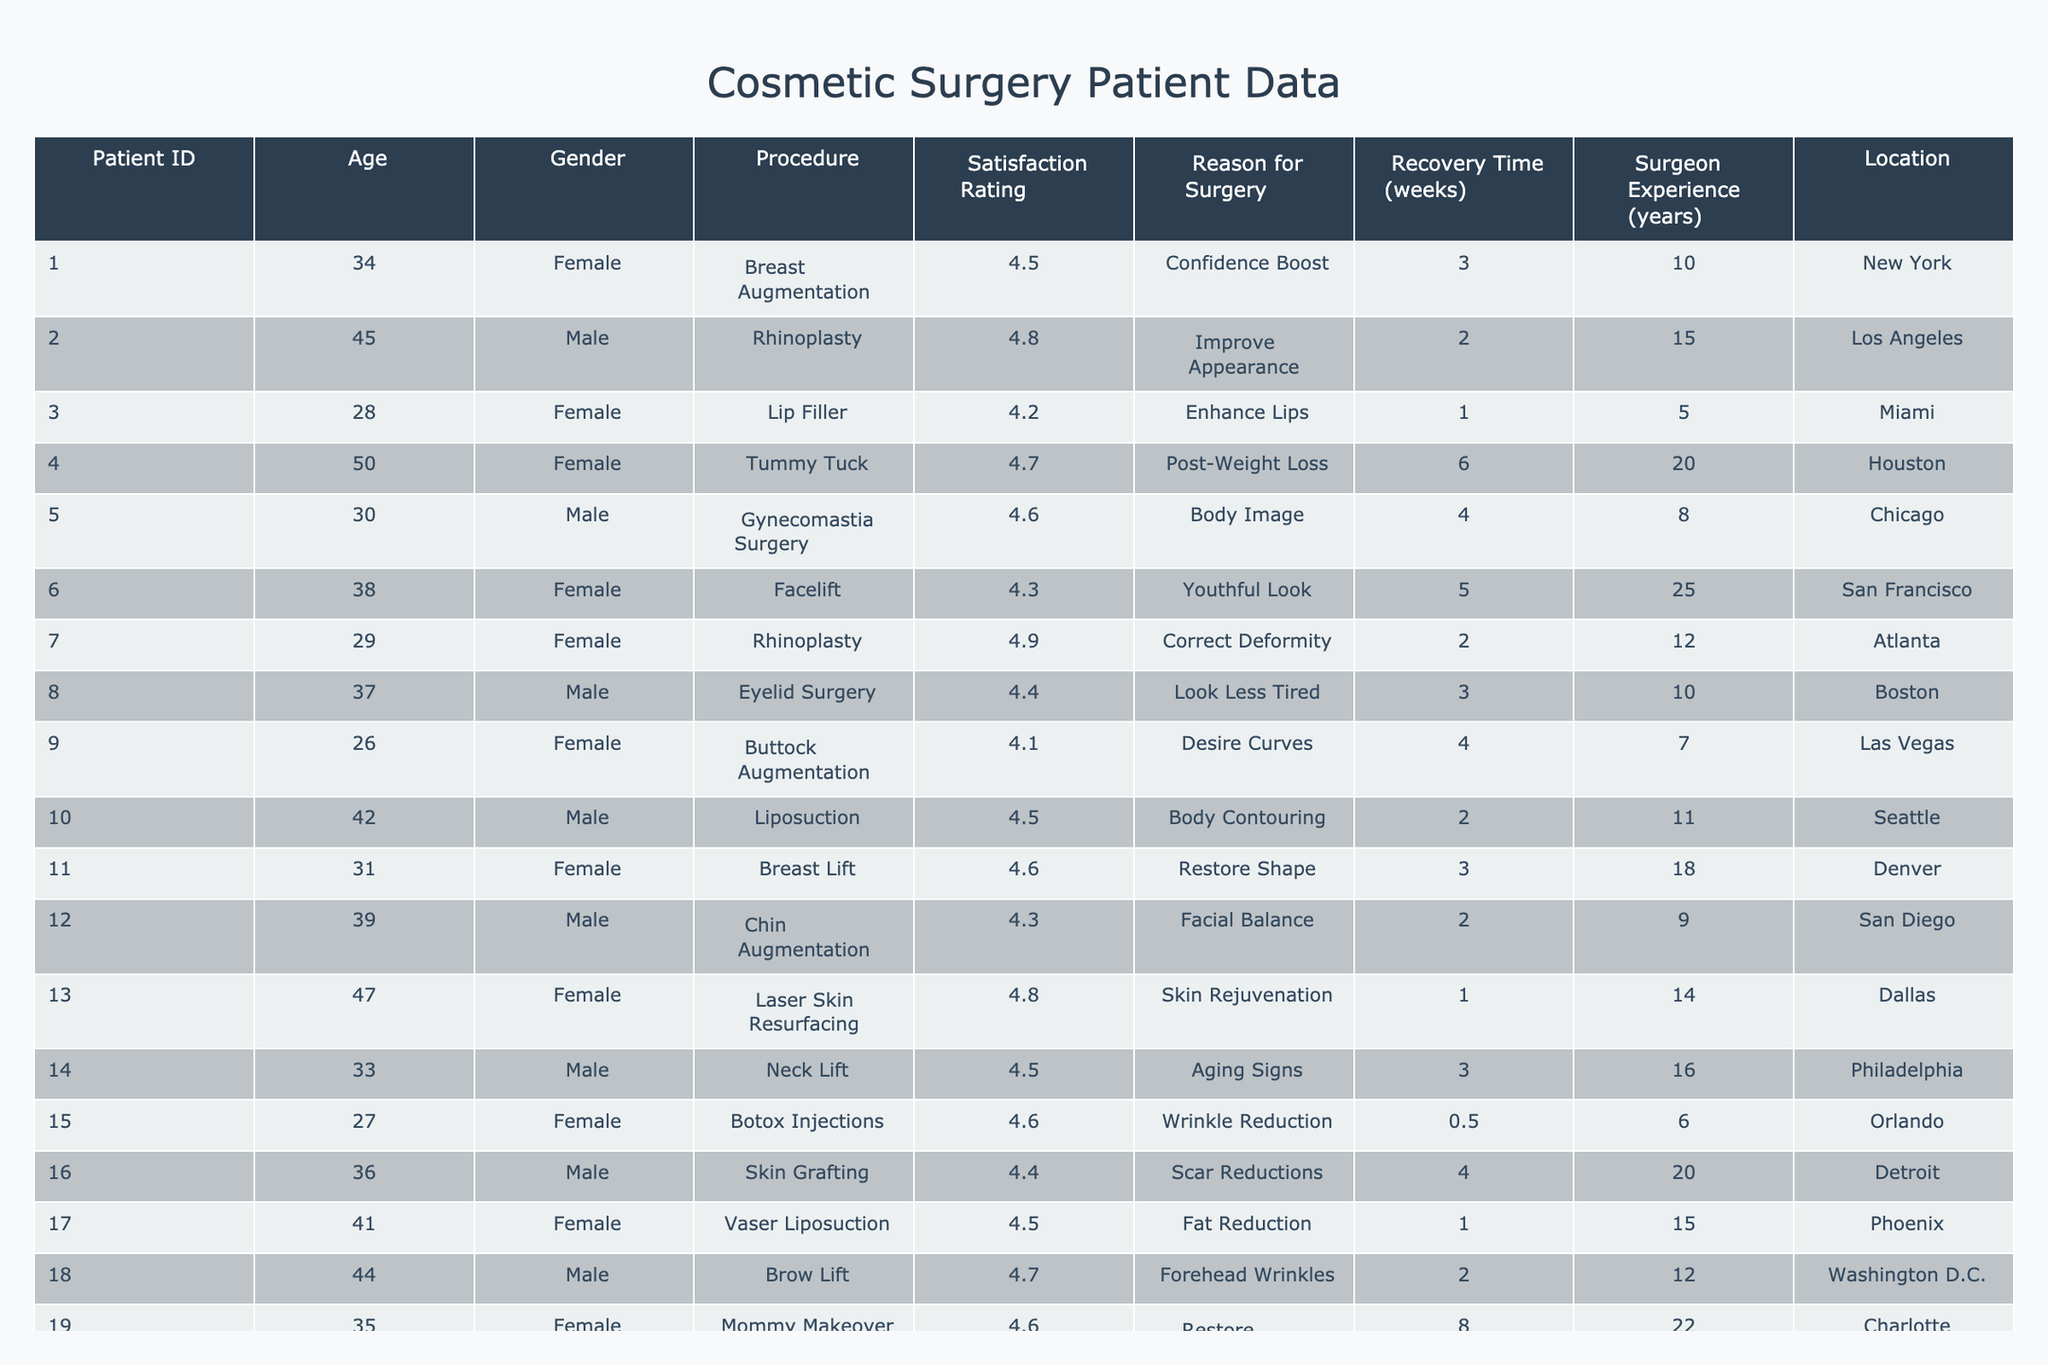What is the satisfaction rating for the Breast Augmentation procedure? In the table, I can find the row with "Breast Augmentation" under the Procedure column. The satisfaction rating in that row is 4.5.
Answer: 4.5 How many patients had a Recovery Time of 2 weeks? By inspecting the table, there are three patients (IDs 2, 12, and 18) who had a Recovery Time of 2 weeks.
Answer: 3 What is the average satisfaction rating for male patients? To find the average for male patients, I sum their satisfaction ratings: 4.8 (Rhinoplasty) + 4.6 (Gynecomastia Surgery) + 4.4 (Eyelid Surgery) + 4.3 (Chin Augmentation) + 4.5 (Neck Lift) + 4.4 (Skin Grafting) + 4.7 (Brow Lift) + 4.2 (Arm Lift) = 35.9. There are 8 male patients, so the average is 35.9 / 8 = 4.4875, rounded to 4.49.
Answer: 4.49 Which procedure had the longest Recovery Time, and what was that time? The longest Recovery Time listed in the table is 8 weeks, associated with the Mommy Makeover procedure performed on a 35-year-old female patient.
Answer: Mommy Makeover, 8 weeks Is the satisfaction of patients who underwent Facelift higher than those who had Botox Injections? The satisfaction rating for Facelift is 4.3, while for Botox Injections, it is 4.6. Since 4.3 is not higher than 4.6, the answer is no.
Answer: No What is the difference in satisfaction ratings between the highest and lowest rated procedures? The highest satisfaction rating is for the Rhinoplasty procedure with a rating of 4.9, and the lowest is for Buttock Augmentation, with a rating of 4.1. The difference is 4.9 - 4.1 = 0.8.
Answer: 0.8 How many female patients wanted surgery for a "Confidence Boost"? Looking at the table, there is one female patient (ID 1) who specified "Confidence Boost" as their reason for surgery.
Answer: 1 What percentage of patients experienced a Recovery Time of 4 weeks or longer? There are a total of 20 patients. The patients with a Recovery Time of 4 weeks or longer are an ID 4, 5, 9, 19, and 6 (ID 5 is the only one below 4). Therefore, 5 patients out of 20 had a Recovery Time of 4 weeks or longer. The percentage is (5/20) * 100 = 25%.
Answer: 25% What are the most common reasons for surgery among the patients? By reviewing the data, "Improve Appearance" and "Restoring Body Shape" appear frequently among the reasons. "Confidence Boost" is also recurring.
Answer: Improve Appearance, Restore Body Shape, Confidence Boost 